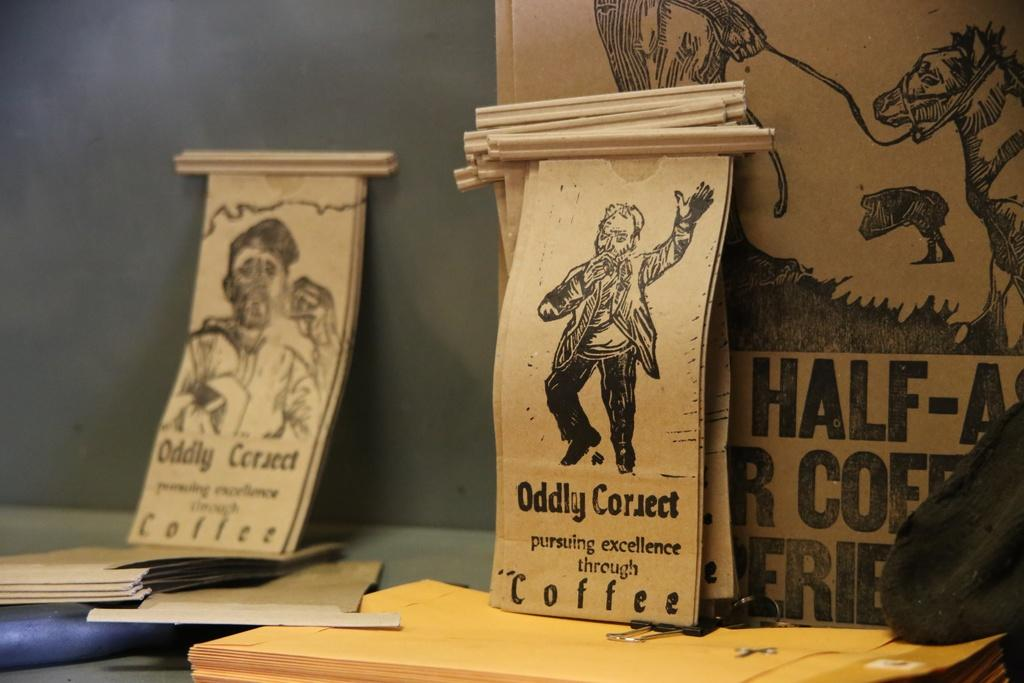<image>
Summarize the visual content of the image. Some small bags are labeled with ODDLY CORRECT COFFEE. 